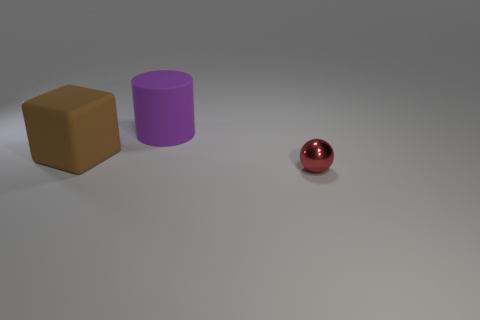What number of red metallic objects are the same size as the sphere?
Your answer should be very brief. 0. What is the color of the object that is both in front of the big purple rubber object and to the left of the tiny sphere?
Offer a very short reply. Brown. Is the number of balls that are to the left of the purple thing greater than the number of big brown shiny cylinders?
Make the answer very short. No. Is there a cyan metal ball?
Your answer should be compact. No. Does the metal thing have the same color as the large matte block?
Give a very brief answer. No. How many large things are either brown cubes or cylinders?
Provide a short and direct response. 2. Is there any other thing that is the same color as the small metal thing?
Provide a succinct answer. No. What shape is the object that is made of the same material as the big cylinder?
Keep it short and to the point. Cube. What is the size of the matte thing behind the cube?
Provide a short and direct response. Large. What is the shape of the purple matte object?
Offer a very short reply. Cylinder. 